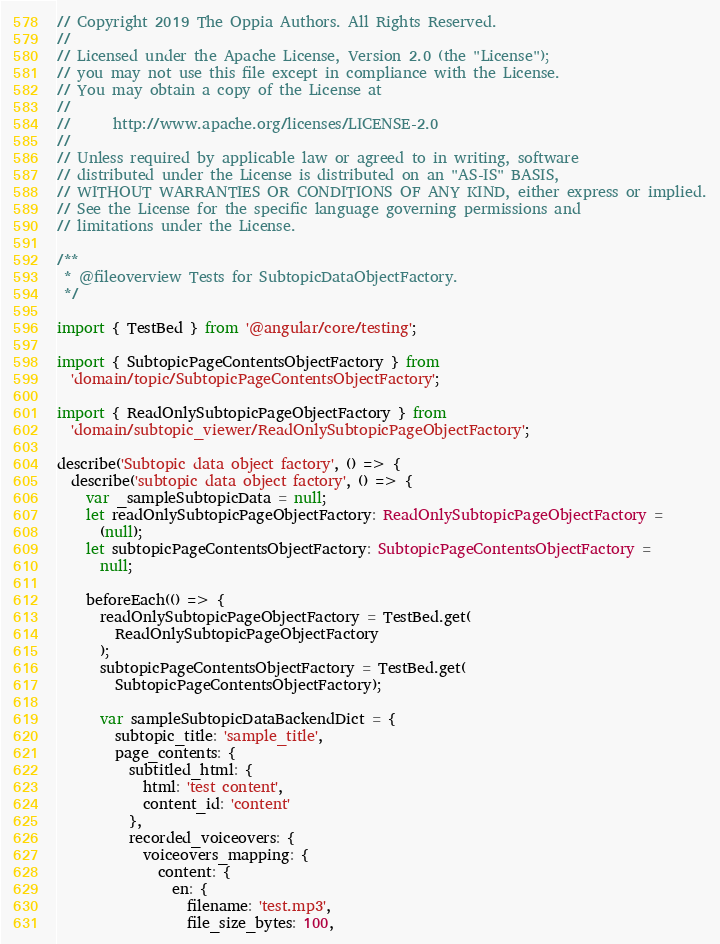<code> <loc_0><loc_0><loc_500><loc_500><_TypeScript_>// Copyright 2019 The Oppia Authors. All Rights Reserved.
//
// Licensed under the Apache License, Version 2.0 (the "License");
// you may not use this file except in compliance with the License.
// You may obtain a copy of the License at
//
//      http://www.apache.org/licenses/LICENSE-2.0
//
// Unless required by applicable law or agreed to in writing, software
// distributed under the License is distributed on an "AS-IS" BASIS,
// WITHOUT WARRANTIES OR CONDITIONS OF ANY KIND, either express or implied.
// See the License for the specific language governing permissions and
// limitations under the License.

/**
 * @fileoverview Tests for SubtopicDataObjectFactory.
 */

import { TestBed } from '@angular/core/testing';

import { SubtopicPageContentsObjectFactory } from
  'domain/topic/SubtopicPageContentsObjectFactory';

import { ReadOnlySubtopicPageObjectFactory } from
  'domain/subtopic_viewer/ReadOnlySubtopicPageObjectFactory';

describe('Subtopic data object factory', () => {
  describe('subtopic data object factory', () => {
    var _sampleSubtopicData = null;
    let readOnlySubtopicPageObjectFactory: ReadOnlySubtopicPageObjectFactory =
      (null);
    let subtopicPageContentsObjectFactory: SubtopicPageContentsObjectFactory =
      null;

    beforeEach(() => {
      readOnlySubtopicPageObjectFactory = TestBed.get(
        ReadOnlySubtopicPageObjectFactory
      );
      subtopicPageContentsObjectFactory = TestBed.get(
        SubtopicPageContentsObjectFactory);

      var sampleSubtopicDataBackendDict = {
        subtopic_title: 'sample_title',
        page_contents: {
          subtitled_html: {
            html: 'test content',
            content_id: 'content'
          },
          recorded_voiceovers: {
            voiceovers_mapping: {
              content: {
                en: {
                  filename: 'test.mp3',
                  file_size_bytes: 100,</code> 